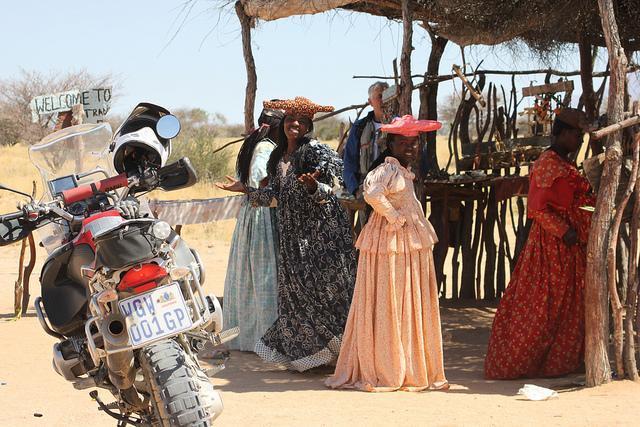How many people are shown?
Give a very brief answer. 5. How many people are in the picture?
Give a very brief answer. 5. How many cats are there?
Give a very brief answer. 0. 